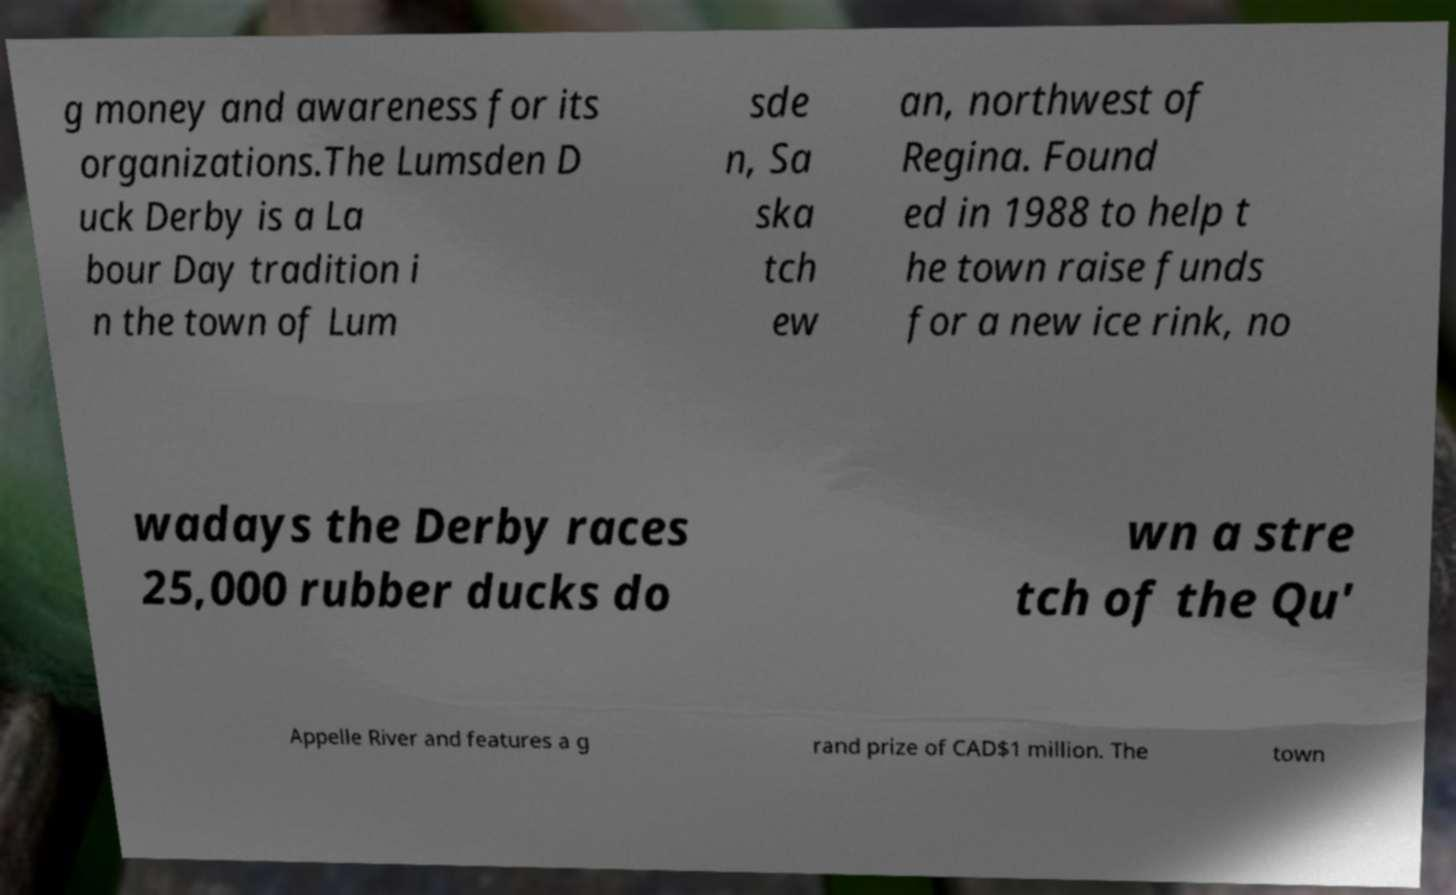I need the written content from this picture converted into text. Can you do that? g money and awareness for its organizations.The Lumsden D uck Derby is a La bour Day tradition i n the town of Lum sde n, Sa ska tch ew an, northwest of Regina. Found ed in 1988 to help t he town raise funds for a new ice rink, no wadays the Derby races 25,000 rubber ducks do wn a stre tch of the Qu' Appelle River and features a g rand prize of CAD$1 million. The town 